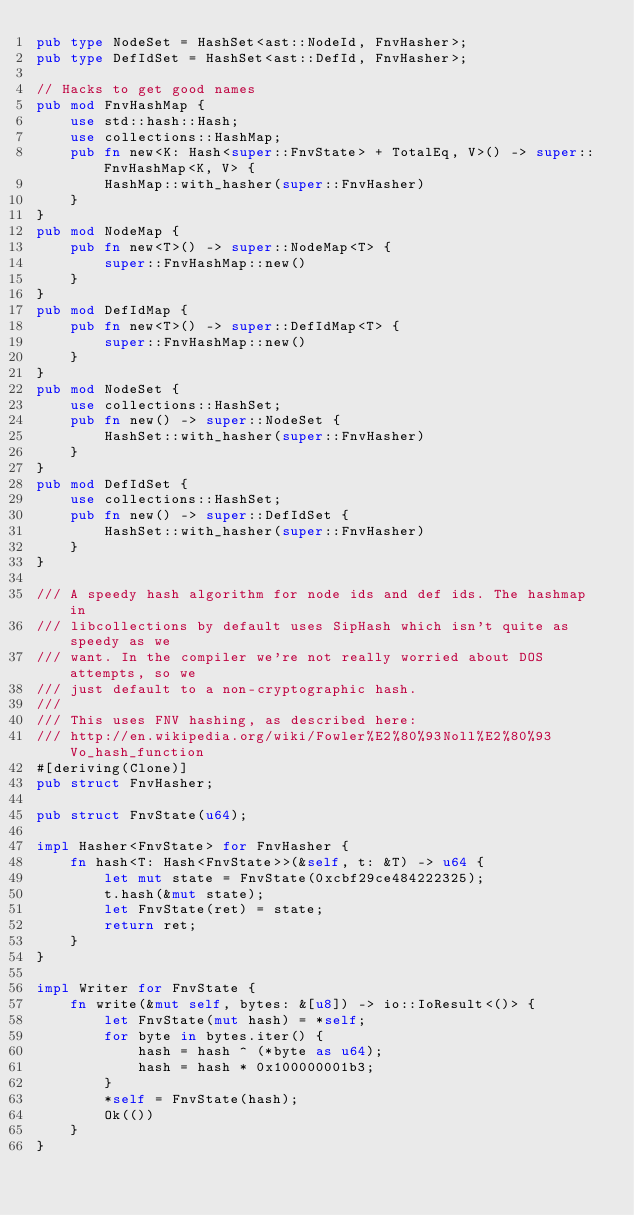Convert code to text. <code><loc_0><loc_0><loc_500><loc_500><_Rust_>pub type NodeSet = HashSet<ast::NodeId, FnvHasher>;
pub type DefIdSet = HashSet<ast::DefId, FnvHasher>;

// Hacks to get good names
pub mod FnvHashMap {
    use std::hash::Hash;
    use collections::HashMap;
    pub fn new<K: Hash<super::FnvState> + TotalEq, V>() -> super::FnvHashMap<K, V> {
        HashMap::with_hasher(super::FnvHasher)
    }
}
pub mod NodeMap {
    pub fn new<T>() -> super::NodeMap<T> {
        super::FnvHashMap::new()
    }
}
pub mod DefIdMap {
    pub fn new<T>() -> super::DefIdMap<T> {
        super::FnvHashMap::new()
    }
}
pub mod NodeSet {
    use collections::HashSet;
    pub fn new() -> super::NodeSet {
        HashSet::with_hasher(super::FnvHasher)
    }
}
pub mod DefIdSet {
    use collections::HashSet;
    pub fn new() -> super::DefIdSet {
        HashSet::with_hasher(super::FnvHasher)
    }
}

/// A speedy hash algorithm for node ids and def ids. The hashmap in
/// libcollections by default uses SipHash which isn't quite as speedy as we
/// want. In the compiler we're not really worried about DOS attempts, so we
/// just default to a non-cryptographic hash.
///
/// This uses FNV hashing, as described here:
/// http://en.wikipedia.org/wiki/Fowler%E2%80%93Noll%E2%80%93Vo_hash_function
#[deriving(Clone)]
pub struct FnvHasher;

pub struct FnvState(u64);

impl Hasher<FnvState> for FnvHasher {
    fn hash<T: Hash<FnvState>>(&self, t: &T) -> u64 {
        let mut state = FnvState(0xcbf29ce484222325);
        t.hash(&mut state);
        let FnvState(ret) = state;
        return ret;
    }
}

impl Writer for FnvState {
    fn write(&mut self, bytes: &[u8]) -> io::IoResult<()> {
        let FnvState(mut hash) = *self;
        for byte in bytes.iter() {
            hash = hash ^ (*byte as u64);
            hash = hash * 0x100000001b3;
        }
        *self = FnvState(hash);
        Ok(())
    }
}
</code> 